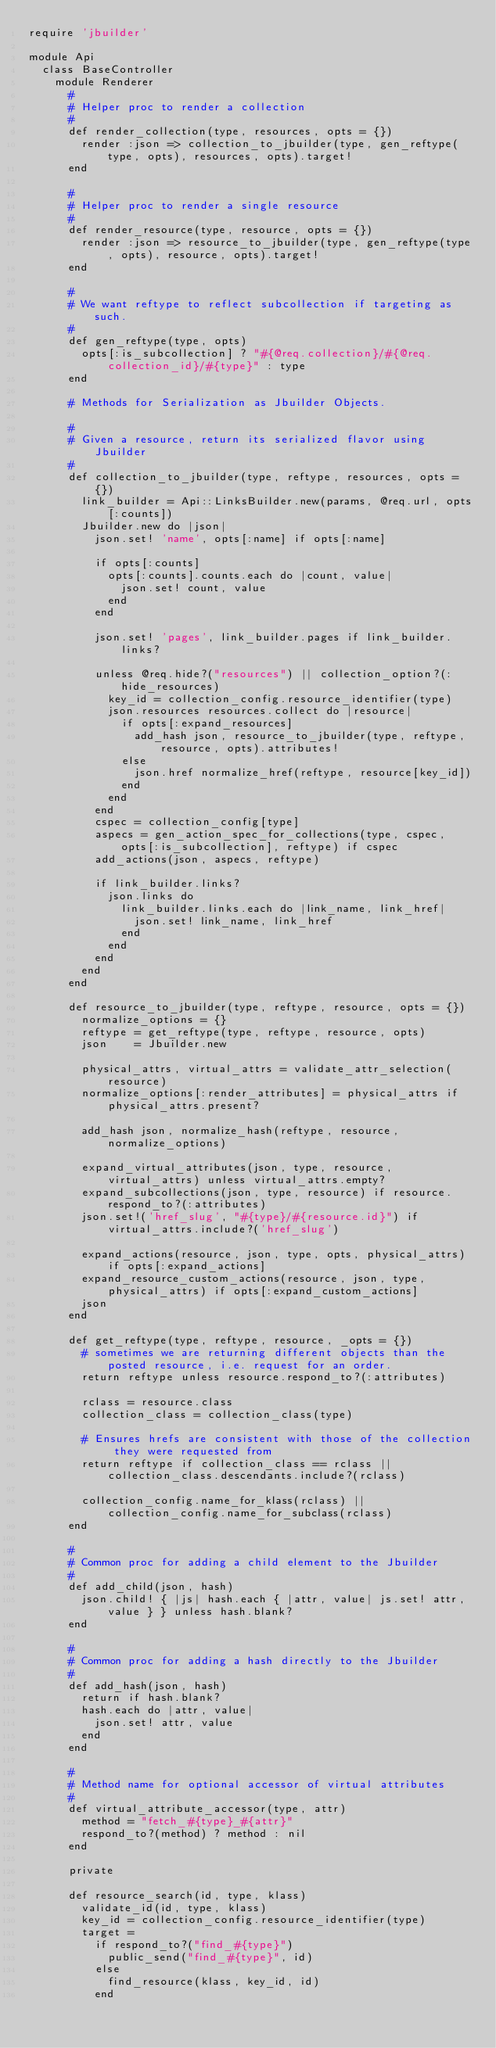Convert code to text. <code><loc_0><loc_0><loc_500><loc_500><_Ruby_>require 'jbuilder'

module Api
  class BaseController
    module Renderer
      #
      # Helper proc to render a collection
      #
      def render_collection(type, resources, opts = {})
        render :json => collection_to_jbuilder(type, gen_reftype(type, opts), resources, opts).target!
      end

      #
      # Helper proc to render a single resource
      #
      def render_resource(type, resource, opts = {})
        render :json => resource_to_jbuilder(type, gen_reftype(type, opts), resource, opts).target!
      end

      #
      # We want reftype to reflect subcollection if targeting as such.
      #
      def gen_reftype(type, opts)
        opts[:is_subcollection] ? "#{@req.collection}/#{@req.collection_id}/#{type}" : type
      end

      # Methods for Serialization as Jbuilder Objects.

      #
      # Given a resource, return its serialized flavor using Jbuilder
      #
      def collection_to_jbuilder(type, reftype, resources, opts = {})
        link_builder = Api::LinksBuilder.new(params, @req.url, opts[:counts])
        Jbuilder.new do |json|
          json.set! 'name', opts[:name] if opts[:name]

          if opts[:counts]
            opts[:counts].counts.each do |count, value|
              json.set! count, value
            end
          end

          json.set! 'pages', link_builder.pages if link_builder.links?

          unless @req.hide?("resources") || collection_option?(:hide_resources)
            key_id = collection_config.resource_identifier(type)
            json.resources resources.collect do |resource|
              if opts[:expand_resources]
                add_hash json, resource_to_jbuilder(type, reftype, resource, opts).attributes!
              else
                json.href normalize_href(reftype, resource[key_id])
              end
            end
          end
          cspec = collection_config[type]
          aspecs = gen_action_spec_for_collections(type, cspec, opts[:is_subcollection], reftype) if cspec
          add_actions(json, aspecs, reftype)

          if link_builder.links?
            json.links do
              link_builder.links.each do |link_name, link_href|
                json.set! link_name, link_href
              end
            end
          end
        end
      end

      def resource_to_jbuilder(type, reftype, resource, opts = {})
        normalize_options = {}
        reftype = get_reftype(type, reftype, resource, opts)
        json    = Jbuilder.new

        physical_attrs, virtual_attrs = validate_attr_selection(resource)
        normalize_options[:render_attributes] = physical_attrs if physical_attrs.present?

        add_hash json, normalize_hash(reftype, resource, normalize_options)

        expand_virtual_attributes(json, type, resource, virtual_attrs) unless virtual_attrs.empty?
        expand_subcollections(json, type, resource) if resource.respond_to?(:attributes)
        json.set!('href_slug', "#{type}/#{resource.id}") if virtual_attrs.include?('href_slug')

        expand_actions(resource, json, type, opts, physical_attrs) if opts[:expand_actions]
        expand_resource_custom_actions(resource, json, type, physical_attrs) if opts[:expand_custom_actions]
        json
      end

      def get_reftype(type, reftype, resource, _opts = {})
        # sometimes we are returning different objects than the posted resource, i.e. request for an order.
        return reftype unless resource.respond_to?(:attributes)

        rclass = resource.class
        collection_class = collection_class(type)

        # Ensures hrefs are consistent with those of the collection they were requested from
        return reftype if collection_class == rclass || collection_class.descendants.include?(rclass)

        collection_config.name_for_klass(rclass) || collection_config.name_for_subclass(rclass)
      end

      #
      # Common proc for adding a child element to the Jbuilder
      #
      def add_child(json, hash)
        json.child! { |js| hash.each { |attr, value| js.set! attr, value } } unless hash.blank?
      end

      #
      # Common proc for adding a hash directly to the Jbuilder
      #
      def add_hash(json, hash)
        return if hash.blank?
        hash.each do |attr, value|
          json.set! attr, value
        end
      end

      #
      # Method name for optional accessor of virtual attributes
      #
      def virtual_attribute_accessor(type, attr)
        method = "fetch_#{type}_#{attr}"
        respond_to?(method) ? method : nil
      end

      private

      def resource_search(id, type, klass)
        validate_id(id, type, klass)
        key_id = collection_config.resource_identifier(type)
        target =
          if respond_to?("find_#{type}")
            public_send("find_#{type}", id)
          else
            find_resource(klass, key_id, id)
          end</code> 